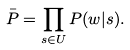<formula> <loc_0><loc_0><loc_500><loc_500>\bar { P } = \prod _ { s \in U } P ( w | s ) .</formula> 